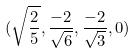Convert formula to latex. <formula><loc_0><loc_0><loc_500><loc_500>( \sqrt { \frac { 2 } { 5 } } , \frac { - 2 } { \sqrt { 6 } } , \frac { - 2 } { \sqrt { 3 } } , 0 )</formula> 